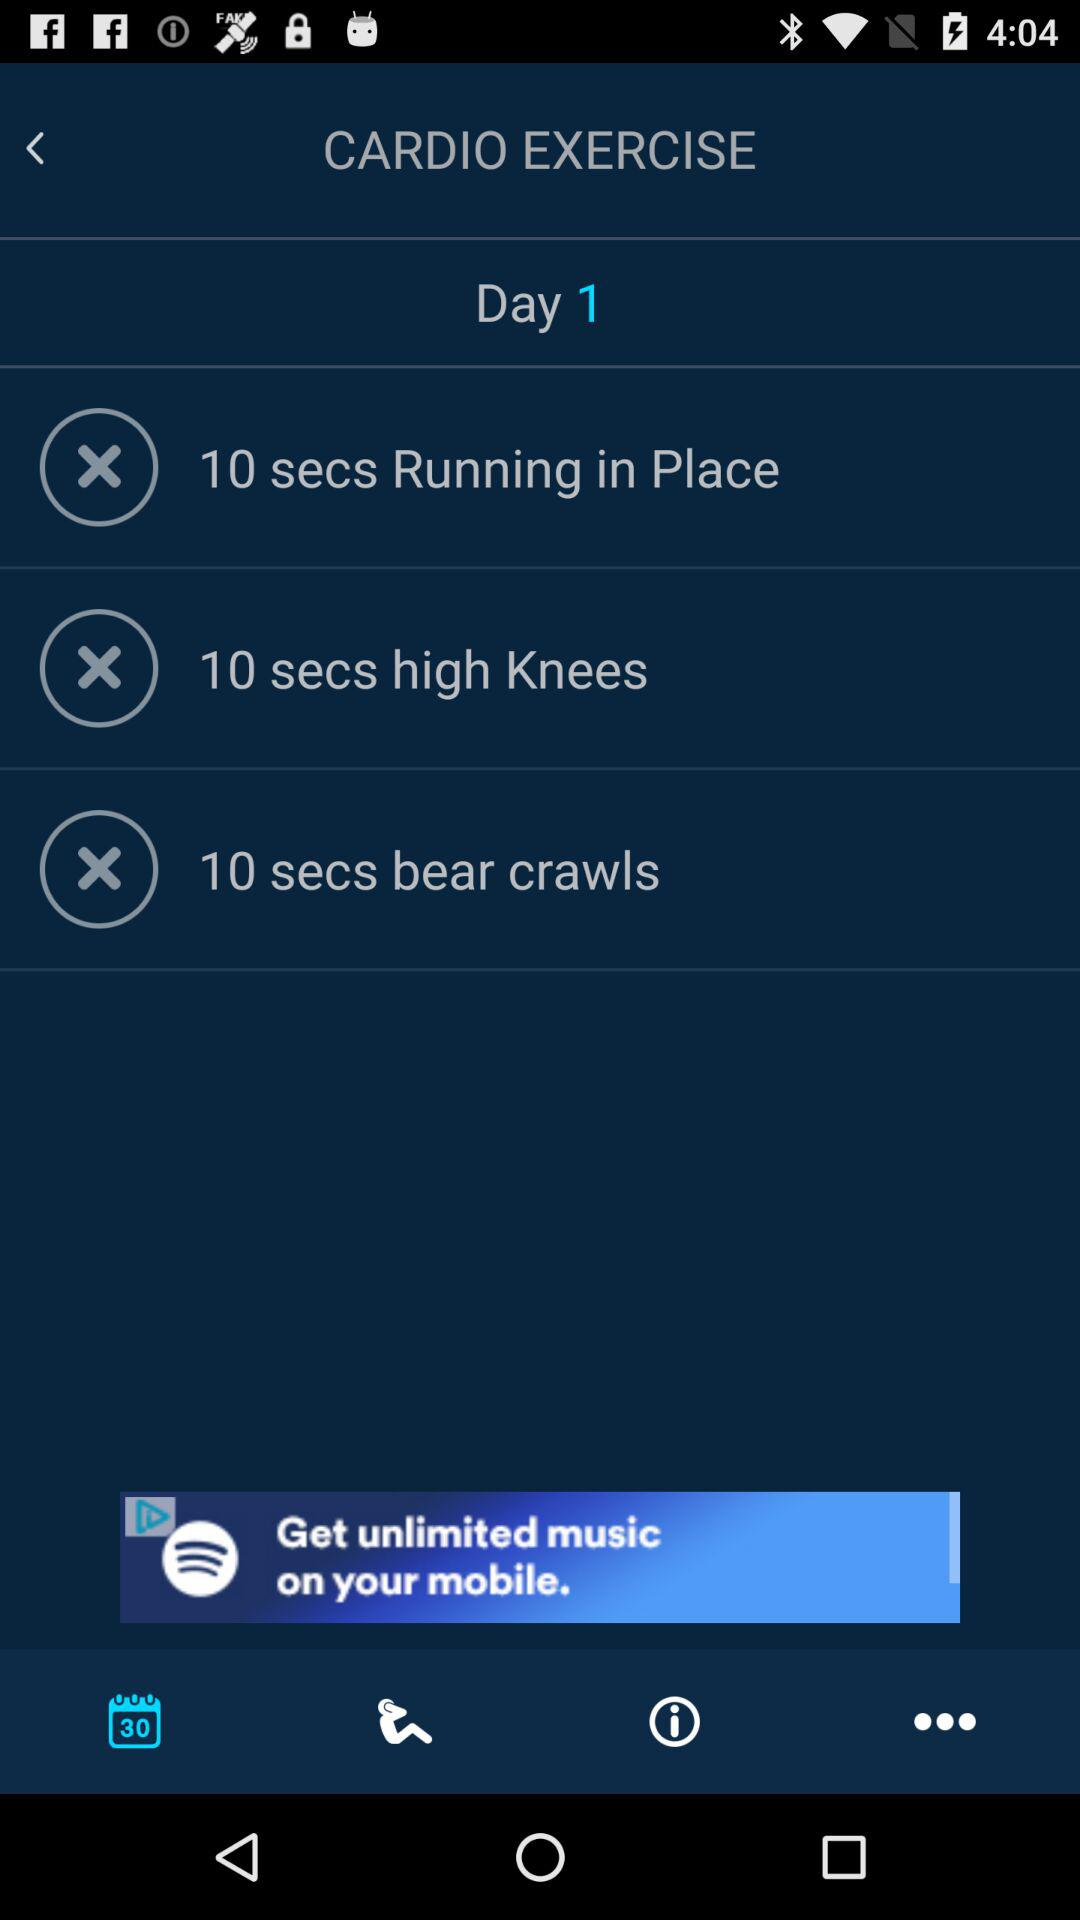How many exercises are in this workout?
Answer the question using a single word or phrase. 3 